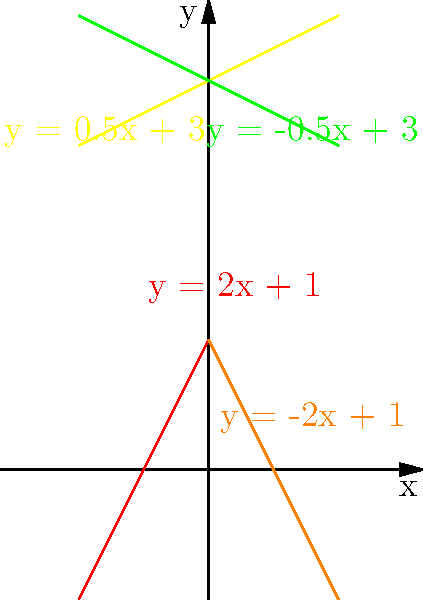In the colorful rainbow pattern shown above, which line represents the equation $y = -2x + 1$? To identify the correct line, let's analyze each equation and its corresponding color:

1. $y = 2x + 1$ (red line): This line has a positive slope and passes through (0, 1).
2. $y = -2x + 1$ (orange line): This line has a negative slope and passes through (0, 1).
3. $y = 0.5x + 3$ (yellow line): This line has a gentle positive slope and passes through (0, 3).
4. $y = -0.5x + 3$ (green line): This line has a gentle negative slope and passes through (0, 3).

The equation we're looking for is $y = -2x + 1$. This equation represents a line with a negative slope (-2) and a y-intercept of 1. Looking at the graph, we can see that the orange line fits this description perfectly.

The orange line starts at the top left of the graph and slopes downward steeply, crossing the y-axis at y = 1. This matches the characteristics of the equation $y = -2x + 1$.
Answer: Orange 